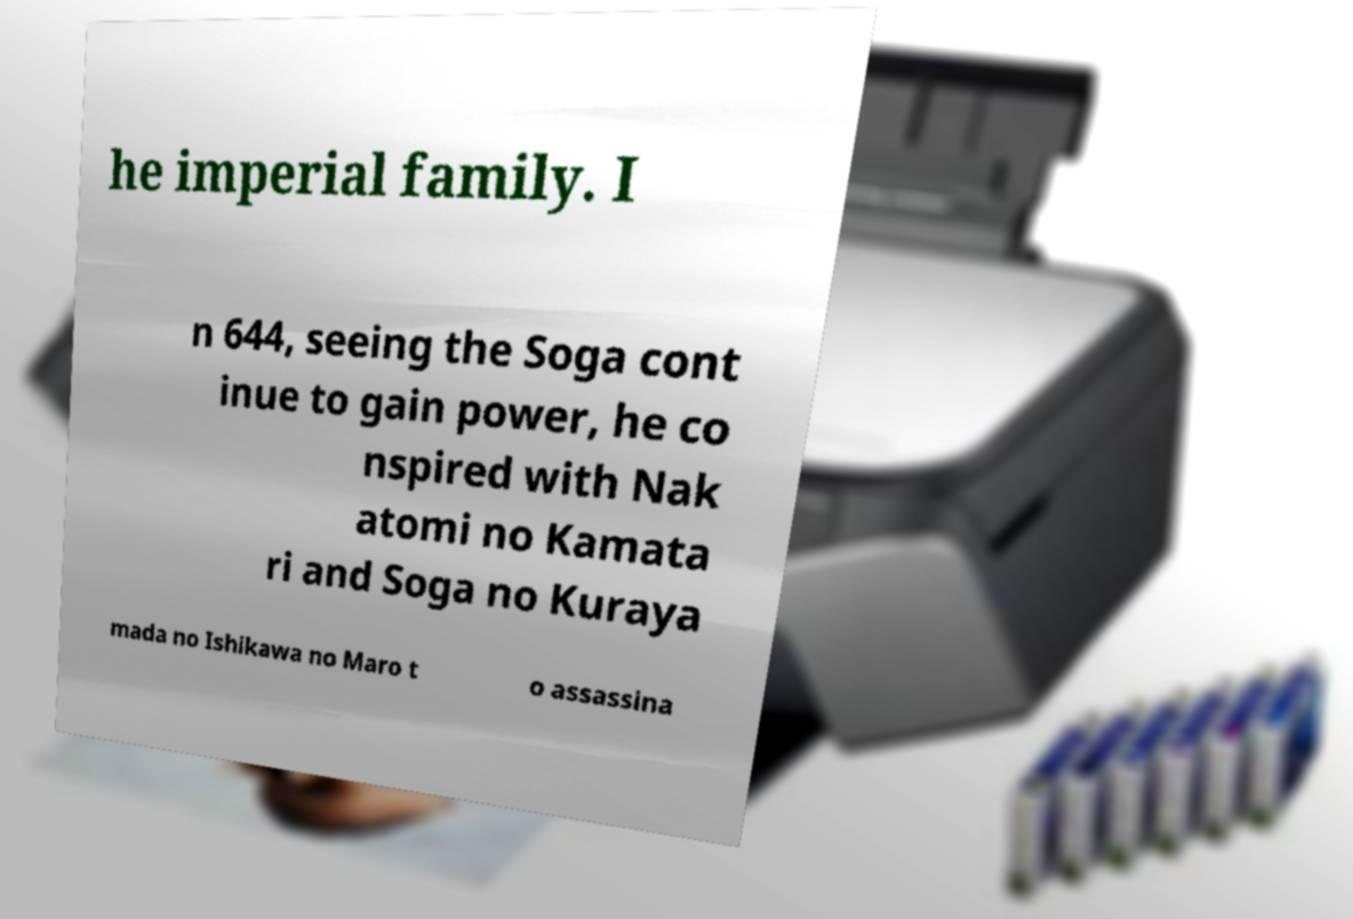Can you read and provide the text displayed in the image?This photo seems to have some interesting text. Can you extract and type it out for me? he imperial family. I n 644, seeing the Soga cont inue to gain power, he co nspired with Nak atomi no Kamata ri and Soga no Kuraya mada no Ishikawa no Maro t o assassina 